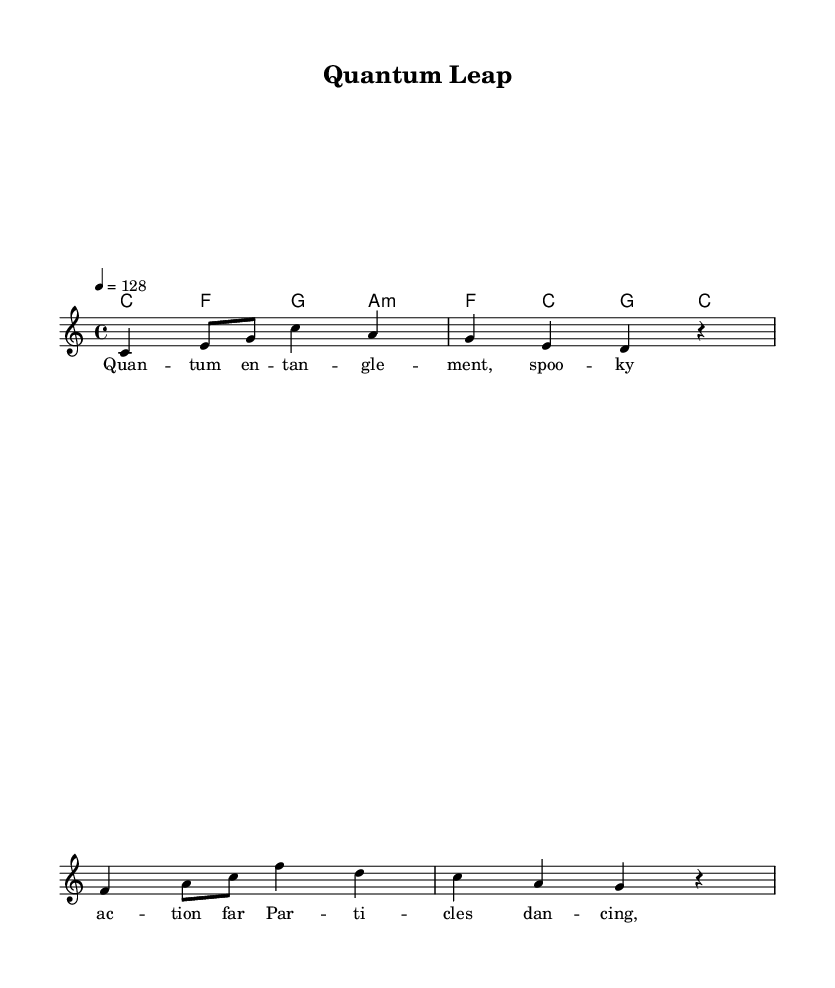What is the key signature of this music? The key signature is C major, which has no sharps or flats.
Answer: C major What is the time signature of this music? The time signature is indicated as 4/4, meaning there are four beats in a measure.
Answer: 4/4 What is the tempo marking in this piece? The tempo marking indicates a speed of 128 beats per minute, portrayed as "4 = 128".
Answer: 128 What are the first two notes of the melody? The first two notes in the melody are "C" and "E", as seen in the first measure.
Answer: C, E How many measures does the melody have in total? The melody has four measures, as divided by the vertical lines in the score.
Answer: 4 What type of chord follows the melody in the first measure? The first measure following the melody shows a C major chord, identified by the chord notation.
Answer: C What lyrical theme is represented in the lyrics of this piece? The lyrics depict themes of quantum entanglement and particle behavior, indicative of scientific breakthroughs.
Answer: Quantum entanglement 